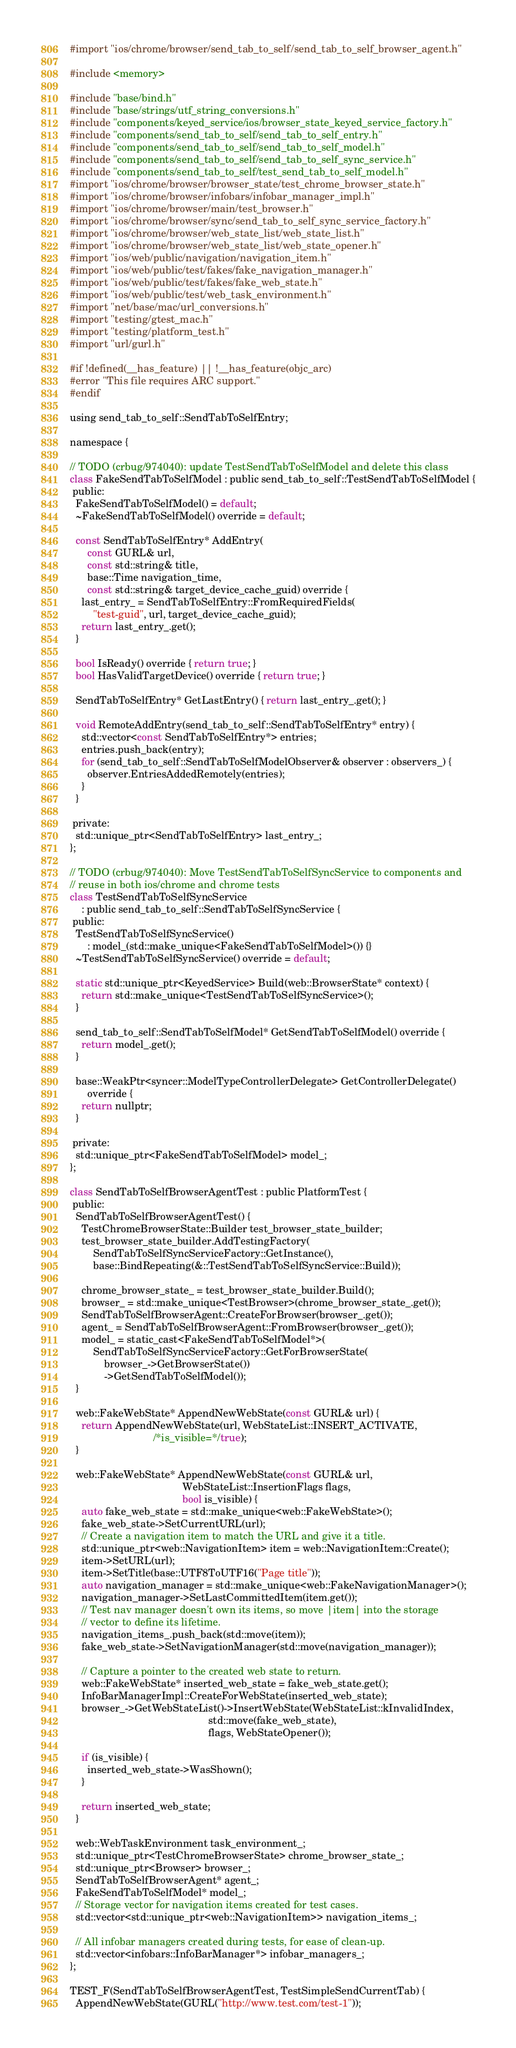Convert code to text. <code><loc_0><loc_0><loc_500><loc_500><_ObjectiveC_>#import "ios/chrome/browser/send_tab_to_self/send_tab_to_self_browser_agent.h"

#include <memory>

#include "base/bind.h"
#include "base/strings/utf_string_conversions.h"
#include "components/keyed_service/ios/browser_state_keyed_service_factory.h"
#include "components/send_tab_to_self/send_tab_to_self_entry.h"
#include "components/send_tab_to_self/send_tab_to_self_model.h"
#include "components/send_tab_to_self/send_tab_to_self_sync_service.h"
#include "components/send_tab_to_self/test_send_tab_to_self_model.h"
#import "ios/chrome/browser/browser_state/test_chrome_browser_state.h"
#import "ios/chrome/browser/infobars/infobar_manager_impl.h"
#import "ios/chrome/browser/main/test_browser.h"
#import "ios/chrome/browser/sync/send_tab_to_self_sync_service_factory.h"
#import "ios/chrome/browser/web_state_list/web_state_list.h"
#import "ios/chrome/browser/web_state_list/web_state_opener.h"
#import "ios/web/public/navigation/navigation_item.h"
#import "ios/web/public/test/fakes/fake_navigation_manager.h"
#import "ios/web/public/test/fakes/fake_web_state.h"
#import "ios/web/public/test/web_task_environment.h"
#import "net/base/mac/url_conversions.h"
#import "testing/gtest_mac.h"
#import "testing/platform_test.h"
#import "url/gurl.h"

#if !defined(__has_feature) || !__has_feature(objc_arc)
#error "This file requires ARC support."
#endif

using send_tab_to_self::SendTabToSelfEntry;

namespace {

// TODO (crbug/974040): update TestSendTabToSelfModel and delete this class
class FakeSendTabToSelfModel : public send_tab_to_self::TestSendTabToSelfModel {
 public:
  FakeSendTabToSelfModel() = default;
  ~FakeSendTabToSelfModel() override = default;

  const SendTabToSelfEntry* AddEntry(
      const GURL& url,
      const std::string& title,
      base::Time navigation_time,
      const std::string& target_device_cache_guid) override {
    last_entry_ = SendTabToSelfEntry::FromRequiredFields(
        "test-guid", url, target_device_cache_guid);
    return last_entry_.get();
  }

  bool IsReady() override { return true; }
  bool HasValidTargetDevice() override { return true; }

  SendTabToSelfEntry* GetLastEntry() { return last_entry_.get(); }

  void RemoteAddEntry(send_tab_to_self::SendTabToSelfEntry* entry) {
    std::vector<const SendTabToSelfEntry*> entries;
    entries.push_back(entry);
    for (send_tab_to_self::SendTabToSelfModelObserver& observer : observers_) {
      observer.EntriesAddedRemotely(entries);
    }
  }

 private:
  std::unique_ptr<SendTabToSelfEntry> last_entry_;
};

// TODO (crbug/974040): Move TestSendTabToSelfSyncService to components and
// reuse in both ios/chrome and chrome tests
class TestSendTabToSelfSyncService
    : public send_tab_to_self::SendTabToSelfSyncService {
 public:
  TestSendTabToSelfSyncService()
      : model_(std::make_unique<FakeSendTabToSelfModel>()) {}
  ~TestSendTabToSelfSyncService() override = default;

  static std::unique_ptr<KeyedService> Build(web::BrowserState* context) {
    return std::make_unique<TestSendTabToSelfSyncService>();
  }

  send_tab_to_self::SendTabToSelfModel* GetSendTabToSelfModel() override {
    return model_.get();
  }

  base::WeakPtr<syncer::ModelTypeControllerDelegate> GetControllerDelegate()
      override {
    return nullptr;
  }

 private:
  std::unique_ptr<FakeSendTabToSelfModel> model_;
};

class SendTabToSelfBrowserAgentTest : public PlatformTest {
 public:
  SendTabToSelfBrowserAgentTest() {
    TestChromeBrowserState::Builder test_browser_state_builder;
    test_browser_state_builder.AddTestingFactory(
        SendTabToSelfSyncServiceFactory::GetInstance(),
        base::BindRepeating(&::TestSendTabToSelfSyncService::Build));

    chrome_browser_state_ = test_browser_state_builder.Build();
    browser_ = std::make_unique<TestBrowser>(chrome_browser_state_.get());
    SendTabToSelfBrowserAgent::CreateForBrowser(browser_.get());
    agent_ = SendTabToSelfBrowserAgent::FromBrowser(browser_.get());
    model_ = static_cast<FakeSendTabToSelfModel*>(
        SendTabToSelfSyncServiceFactory::GetForBrowserState(
            browser_->GetBrowserState())
            ->GetSendTabToSelfModel());
  }

  web::FakeWebState* AppendNewWebState(const GURL& url) {
    return AppendNewWebState(url, WebStateList::INSERT_ACTIVATE,
                             /*is_visible=*/true);
  }

  web::FakeWebState* AppendNewWebState(const GURL& url,
                                       WebStateList::InsertionFlags flags,
                                       bool is_visible) {
    auto fake_web_state = std::make_unique<web::FakeWebState>();
    fake_web_state->SetCurrentURL(url);
    // Create a navigation item to match the URL and give it a title.
    std::unique_ptr<web::NavigationItem> item = web::NavigationItem::Create();
    item->SetURL(url);
    item->SetTitle(base::UTF8ToUTF16("Page title"));
    auto navigation_manager = std::make_unique<web::FakeNavigationManager>();
    navigation_manager->SetLastCommittedItem(item.get());
    // Test nav manager doesn't own its items, so move |item| into the storage
    // vector to define its lifetime.
    navigation_items_.push_back(std::move(item));
    fake_web_state->SetNavigationManager(std::move(navigation_manager));

    // Capture a pointer to the created web state to return.
    web::FakeWebState* inserted_web_state = fake_web_state.get();
    InfoBarManagerImpl::CreateForWebState(inserted_web_state);
    browser_->GetWebStateList()->InsertWebState(WebStateList::kInvalidIndex,
                                                std::move(fake_web_state),
                                                flags, WebStateOpener());

    if (is_visible) {
      inserted_web_state->WasShown();
    }

    return inserted_web_state;
  }

  web::WebTaskEnvironment task_environment_;
  std::unique_ptr<TestChromeBrowserState> chrome_browser_state_;
  std::unique_ptr<Browser> browser_;
  SendTabToSelfBrowserAgent* agent_;
  FakeSendTabToSelfModel* model_;
  // Storage vector for navigation items created for test cases.
  std::vector<std::unique_ptr<web::NavigationItem>> navigation_items_;

  // All infobar managers created during tests, for ease of clean-up.
  std::vector<infobars::InfoBarManager*> infobar_managers_;
};

TEST_F(SendTabToSelfBrowserAgentTest, TestSimpleSendCurrentTab) {
  AppendNewWebState(GURL("http://www.test.com/test-1"));</code> 